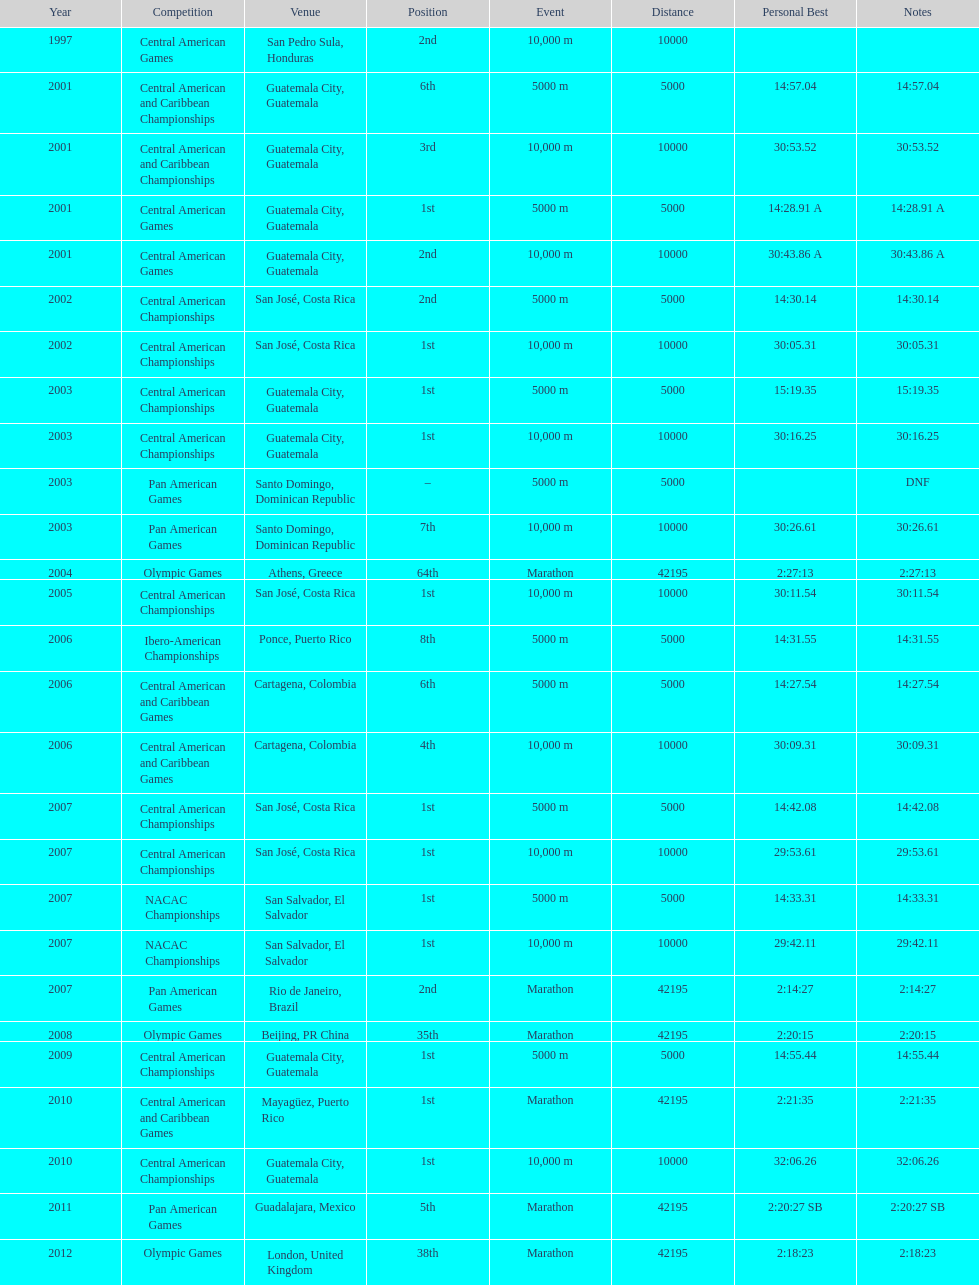Which event is listed more between the 10,000m and the 5000m? 10,000 m. Could you parse the entire table? {'header': ['Year', 'Competition', 'Venue', 'Position', 'Event', 'Distance', 'Personal Best', 'Notes'], 'rows': [['1997', 'Central American Games', 'San Pedro Sula, Honduras', '2nd', '10,000 m', '10000', '', ''], ['2001', 'Central American and Caribbean Championships', 'Guatemala City, Guatemala', '6th', '5000 m', '5000', '14:57.04', '14:57.04'], ['2001', 'Central American and Caribbean Championships', 'Guatemala City, Guatemala', '3rd', '10,000 m', '10000', '30:53.52', '30:53.52'], ['2001', 'Central American Games', 'Guatemala City, Guatemala', '1st', '5000 m', '5000', '14:28.91 A', '14:28.91 A'], ['2001', 'Central American Games', 'Guatemala City, Guatemala', '2nd', '10,000 m', '10000', '30:43.86 A', '30:43.86 A'], ['2002', 'Central American Championships', 'San José, Costa Rica', '2nd', '5000 m', '5000', '14:30.14', '14:30.14'], ['2002', 'Central American Championships', 'San José, Costa Rica', '1st', '10,000 m', '10000', '30:05.31', '30:05.31'], ['2003', 'Central American Championships', 'Guatemala City, Guatemala', '1st', '5000 m', '5000', '15:19.35', '15:19.35'], ['2003', 'Central American Championships', 'Guatemala City, Guatemala', '1st', '10,000 m', '10000', '30:16.25', '30:16.25'], ['2003', 'Pan American Games', 'Santo Domingo, Dominican Republic', '–', '5000 m', '5000', '', 'DNF'], ['2003', 'Pan American Games', 'Santo Domingo, Dominican Republic', '7th', '10,000 m', '10000', '30:26.61', '30:26.61'], ['2004', 'Olympic Games', 'Athens, Greece', '64th', 'Marathon', '42195', '2:27:13', '2:27:13'], ['2005', 'Central American Championships', 'San José, Costa Rica', '1st', '10,000 m', '10000', '30:11.54', '30:11.54'], ['2006', 'Ibero-American Championships', 'Ponce, Puerto Rico', '8th', '5000 m', '5000', '14:31.55', '14:31.55'], ['2006', 'Central American and Caribbean Games', 'Cartagena, Colombia', '6th', '5000 m', '5000', '14:27.54', '14:27.54'], ['2006', 'Central American and Caribbean Games', 'Cartagena, Colombia', '4th', '10,000 m', '10000', '30:09.31', '30:09.31'], ['2007', 'Central American Championships', 'San José, Costa Rica', '1st', '5000 m', '5000', '14:42.08', '14:42.08'], ['2007', 'Central American Championships', 'San José, Costa Rica', '1st', '10,000 m', '10000', '29:53.61', '29:53.61'], ['2007', 'NACAC Championships', 'San Salvador, El Salvador', '1st', '5000 m', '5000', '14:33.31', '14:33.31'], ['2007', 'NACAC Championships', 'San Salvador, El Salvador', '1st', '10,000 m', '10000', '29:42.11', '29:42.11'], ['2007', 'Pan American Games', 'Rio de Janeiro, Brazil', '2nd', 'Marathon', '42195', '2:14:27', '2:14:27'], ['2008', 'Olympic Games', 'Beijing, PR China', '35th', 'Marathon', '42195', '2:20:15', '2:20:15'], ['2009', 'Central American Championships', 'Guatemala City, Guatemala', '1st', '5000 m', '5000', '14:55.44', '14:55.44'], ['2010', 'Central American and Caribbean Games', 'Mayagüez, Puerto Rico', '1st', 'Marathon', '42195', '2:21:35', '2:21:35'], ['2010', 'Central American Championships', 'Guatemala City, Guatemala', '1st', '10,000 m', '10000', '32:06.26', '32:06.26'], ['2011', 'Pan American Games', 'Guadalajara, Mexico', '5th', 'Marathon', '42195', '2:20:27 SB', '2:20:27 SB'], ['2012', 'Olympic Games', 'London, United Kingdom', '38th', 'Marathon', '42195', '2:18:23', '2:18:23']]} 